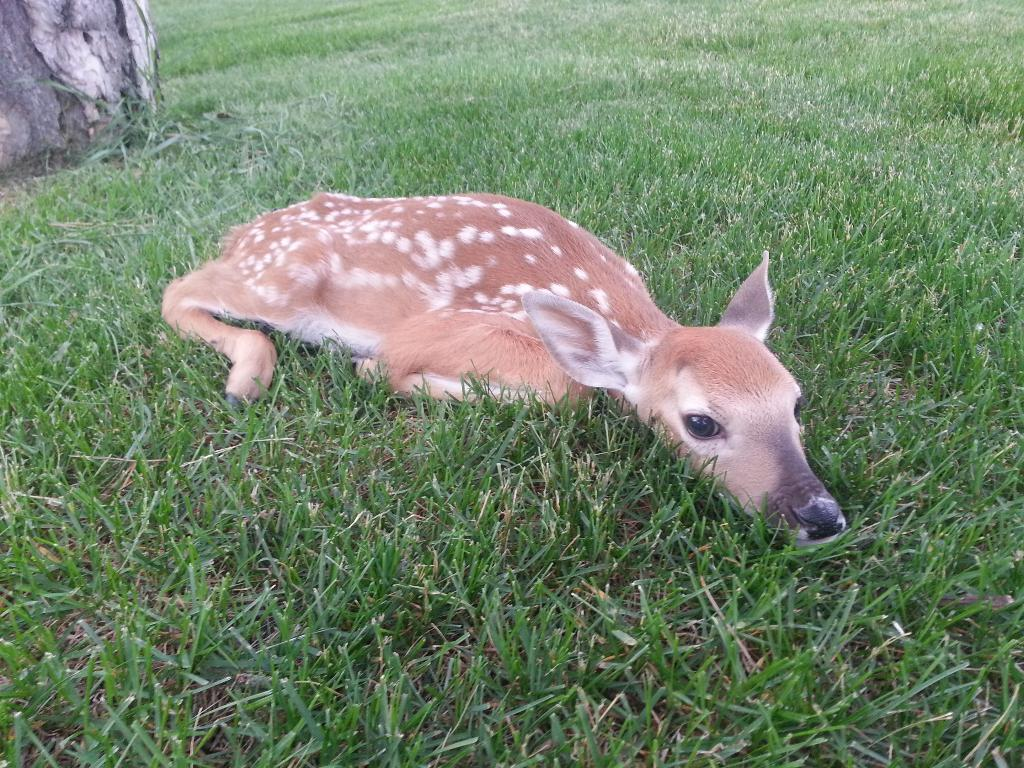What animal can be seen in the image? There is a deer in the image. What is the deer doing in the image? The deer is lying on the grass. What other object is present in the image? There is a tree trunk in the image. What type of cracker is the deer holding in the image? There is no cracker present in the image, and the deer is not holding anything. 